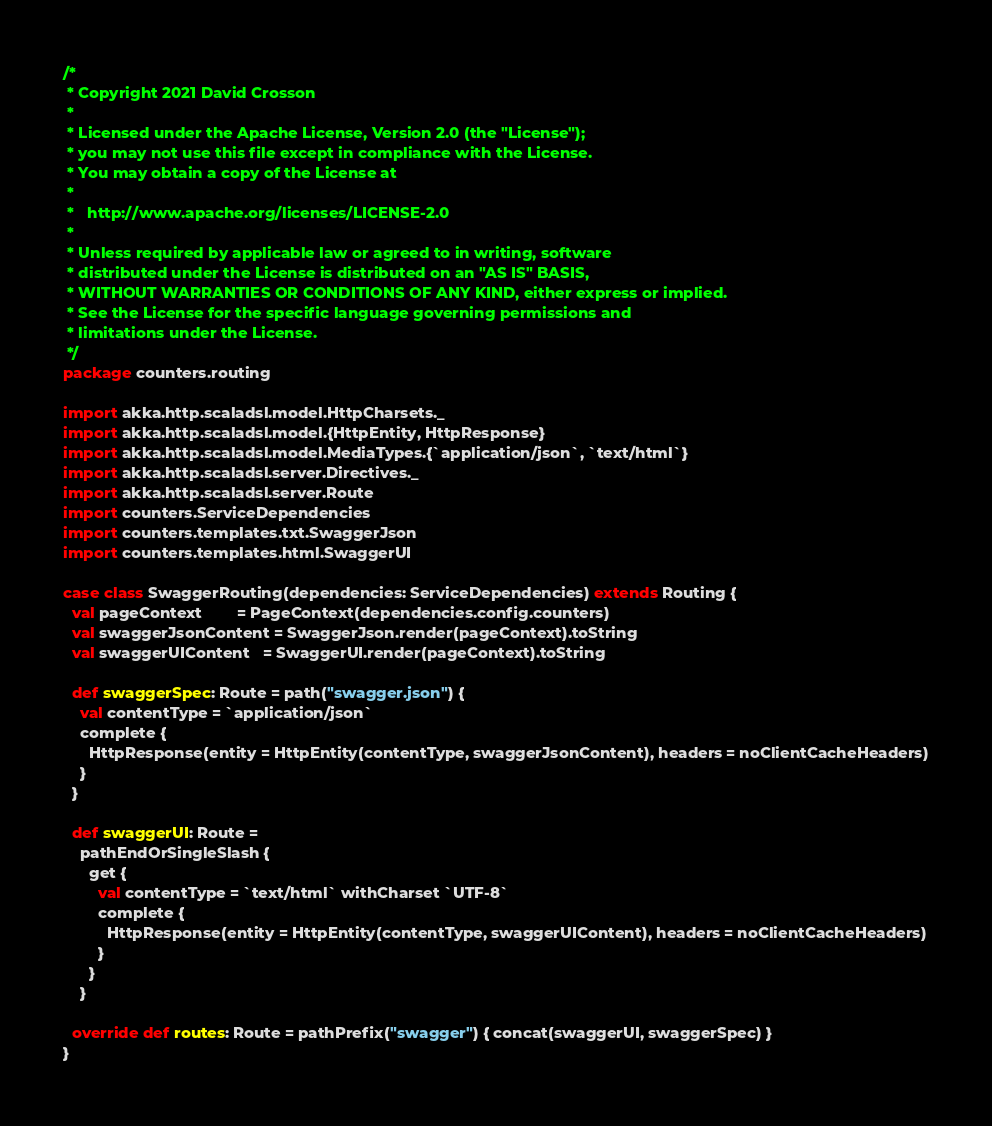<code> <loc_0><loc_0><loc_500><loc_500><_Scala_>/*
 * Copyright 2021 David Crosson
 *
 * Licensed under the Apache License, Version 2.0 (the "License");
 * you may not use this file except in compliance with the License.
 * You may obtain a copy of the License at
 *
 *   http://www.apache.org/licenses/LICENSE-2.0
 *
 * Unless required by applicable law or agreed to in writing, software
 * distributed under the License is distributed on an "AS IS" BASIS,
 * WITHOUT WARRANTIES OR CONDITIONS OF ANY KIND, either express or implied.
 * See the License for the specific language governing permissions and
 * limitations under the License.
 */
package counters.routing

import akka.http.scaladsl.model.HttpCharsets._
import akka.http.scaladsl.model.{HttpEntity, HttpResponse}
import akka.http.scaladsl.model.MediaTypes.{`application/json`, `text/html`}
import akka.http.scaladsl.server.Directives._
import akka.http.scaladsl.server.Route
import counters.ServiceDependencies
import counters.templates.txt.SwaggerJson
import counters.templates.html.SwaggerUI

case class SwaggerRouting(dependencies: ServiceDependencies) extends Routing {
  val pageContext        = PageContext(dependencies.config.counters)
  val swaggerJsonContent = SwaggerJson.render(pageContext).toString
  val swaggerUIContent   = SwaggerUI.render(pageContext).toString

  def swaggerSpec: Route = path("swagger.json") {
    val contentType = `application/json`
    complete {
      HttpResponse(entity = HttpEntity(contentType, swaggerJsonContent), headers = noClientCacheHeaders)
    }
  }

  def swaggerUI: Route =
    pathEndOrSingleSlash {
      get {
        val contentType = `text/html` withCharset `UTF-8`
        complete {
          HttpResponse(entity = HttpEntity(contentType, swaggerUIContent), headers = noClientCacheHeaders)
        }
      }
    }

  override def routes: Route = pathPrefix("swagger") { concat(swaggerUI, swaggerSpec) }
}
</code> 